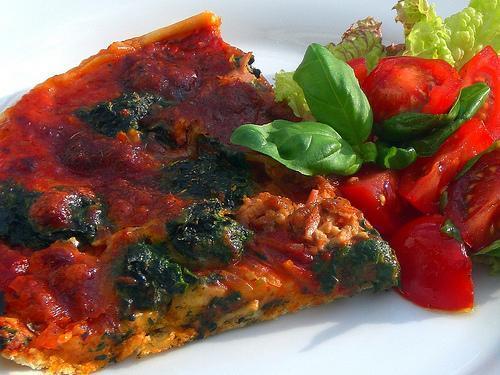How many people are there?
Give a very brief answer. 0. 